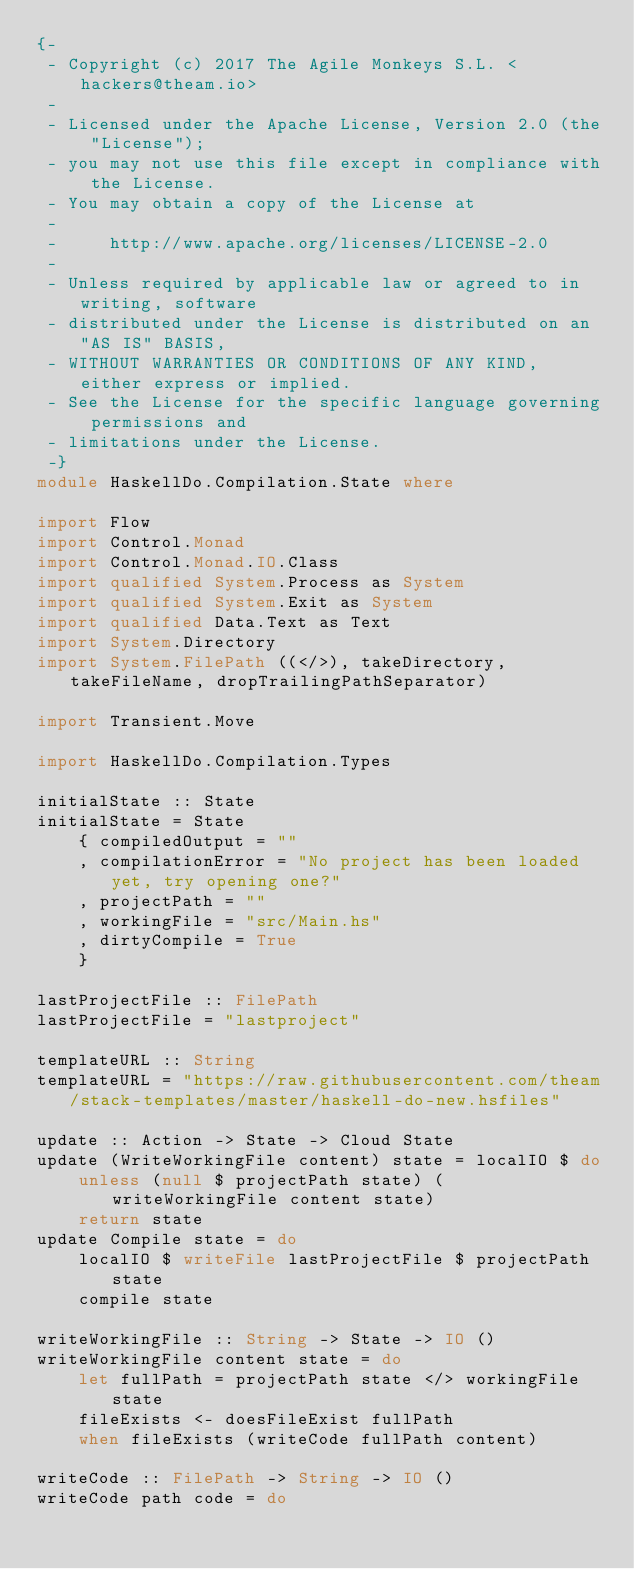<code> <loc_0><loc_0><loc_500><loc_500><_Haskell_>{-
 - Copyright (c) 2017 The Agile Monkeys S.L. <hackers@theam.io>
 -
 - Licensed under the Apache License, Version 2.0 (the "License");
 - you may not use this file except in compliance with the License.
 - You may obtain a copy of the License at
 -
 -     http://www.apache.org/licenses/LICENSE-2.0
 -
 - Unless required by applicable law or agreed to in writing, software
 - distributed under the License is distributed on an "AS IS" BASIS,
 - WITHOUT WARRANTIES OR CONDITIONS OF ANY KIND, either express or implied.
 - See the License for the specific language governing permissions and
 - limitations under the License.
 -}
module HaskellDo.Compilation.State where

import Flow
import Control.Monad
import Control.Monad.IO.Class
import qualified System.Process as System
import qualified System.Exit as System
import qualified Data.Text as Text
import System.Directory
import System.FilePath ((</>), takeDirectory, takeFileName, dropTrailingPathSeparator)

import Transient.Move

import HaskellDo.Compilation.Types

initialState :: State
initialState = State
    { compiledOutput = ""
    , compilationError = "No project has been loaded yet, try opening one?"
    , projectPath = ""
    , workingFile = "src/Main.hs"
    , dirtyCompile = True
    }

lastProjectFile :: FilePath
lastProjectFile = "lastproject"

templateURL :: String
templateURL = "https://raw.githubusercontent.com/theam/stack-templates/master/haskell-do-new.hsfiles"

update :: Action -> State -> Cloud State
update (WriteWorkingFile content) state = localIO $ do
    unless (null $ projectPath state) (writeWorkingFile content state)
    return state
update Compile state = do
    localIO $ writeFile lastProjectFile $ projectPath state
    compile state

writeWorkingFile :: String -> State -> IO ()
writeWorkingFile content state = do
    let fullPath = projectPath state </> workingFile state
    fileExists <- doesFileExist fullPath
    when fileExists (writeCode fullPath content)

writeCode :: FilePath -> String -> IO ()
writeCode path code = do</code> 